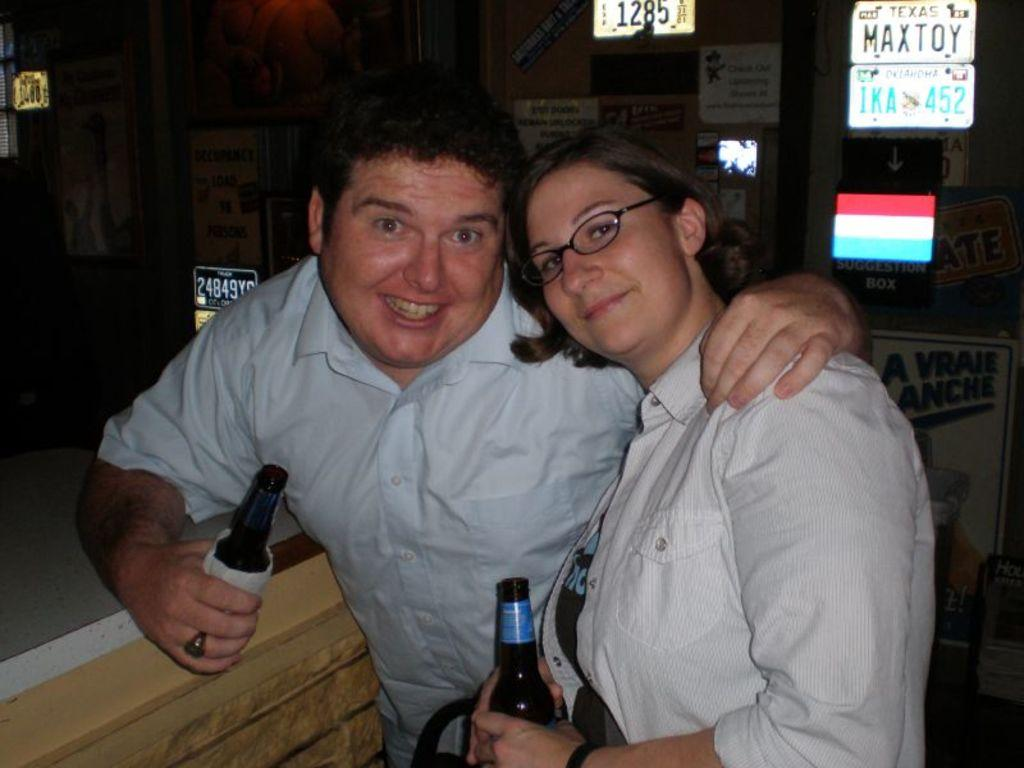How many people are in the image? There are two persons in the image. What are the persons holding in their hands? The persons are holding bottles. Can you identify any specific details about the objects behind the people? There are registration plates visible in the image. What type of tin can be seen producing steam in the image? There is no tin or steam present in the image. Can you describe the seashore visible in the background of the image? There is no seashore visible in the image; it does not depict a coastal scene. 